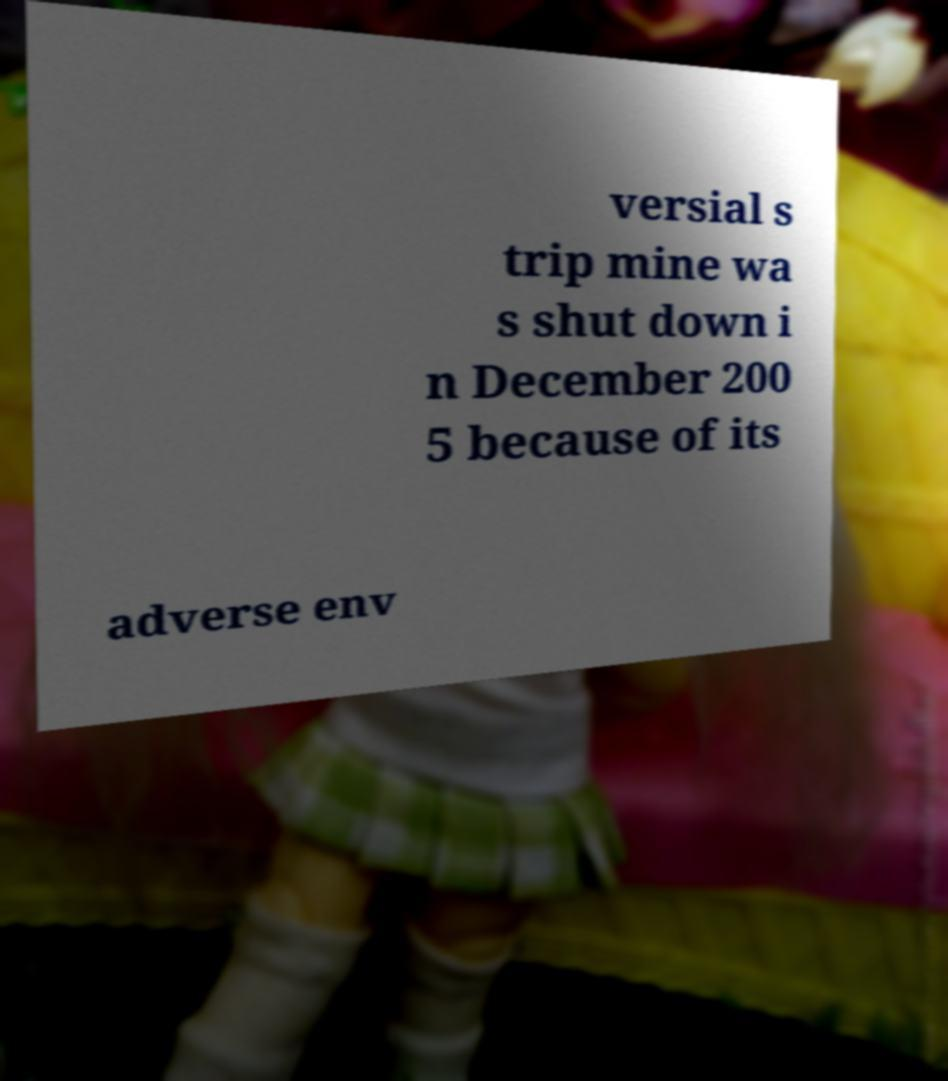Please identify and transcribe the text found in this image. versial s trip mine wa s shut down i n December 200 5 because of its adverse env 